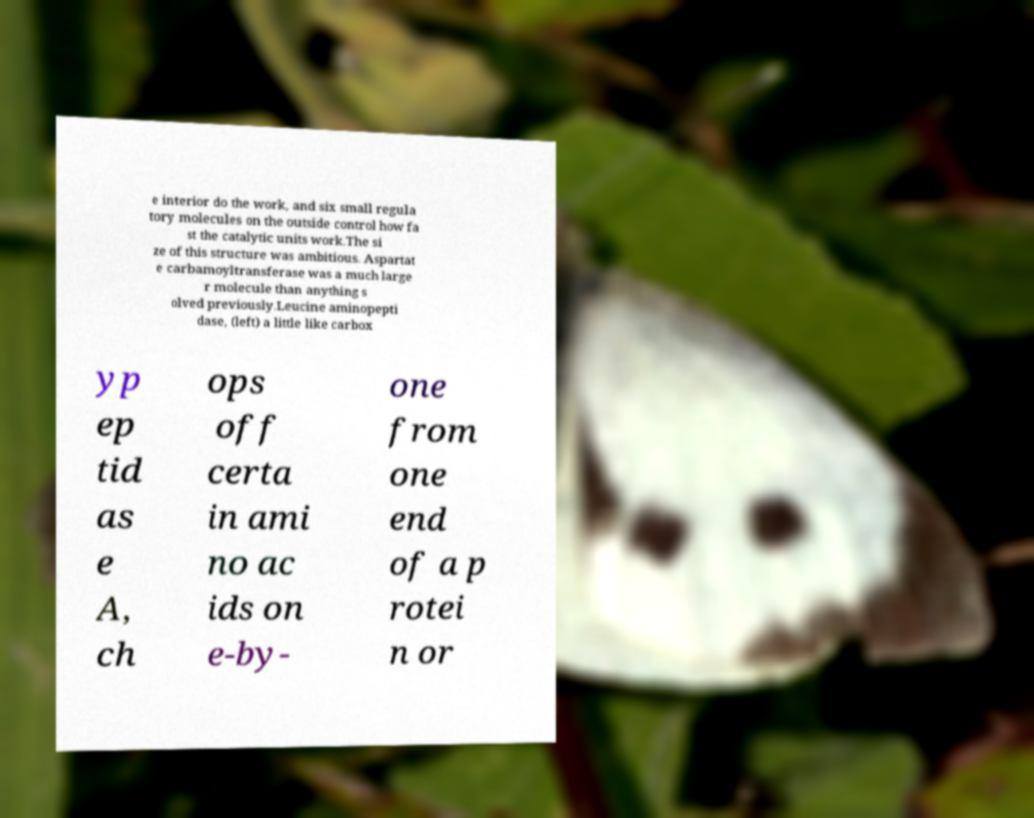There's text embedded in this image that I need extracted. Can you transcribe it verbatim? e interior do the work, and six small regula tory molecules on the outside control how fa st the catalytic units work.The si ze of this structure was ambitious. Aspartat e carbamoyltransferase was a much large r molecule than anything s olved previously.Leucine aminopepti dase, (left) a little like carbox yp ep tid as e A, ch ops off certa in ami no ac ids on e-by- one from one end of a p rotei n or 